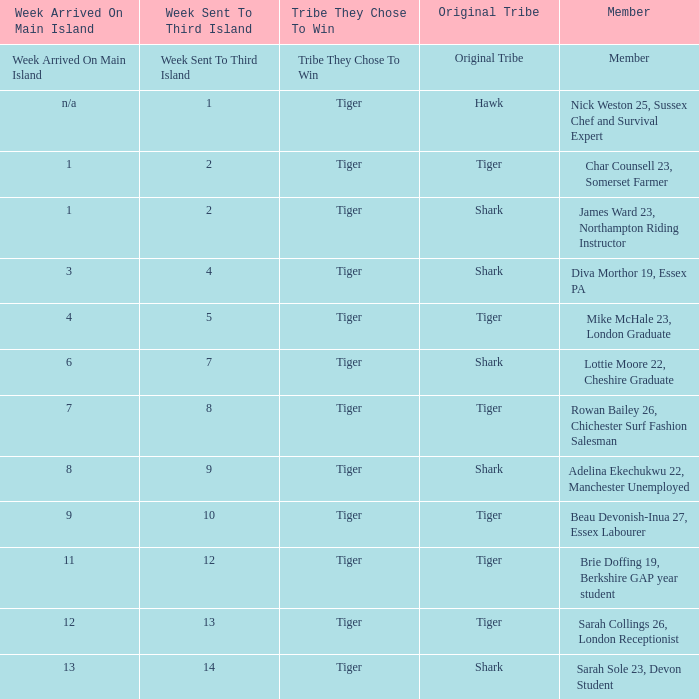Who was sent to the third island in week 1? Nick Weston 25, Sussex Chef and Survival Expert. Would you be able to parse every entry in this table? {'header': ['Week Arrived On Main Island', 'Week Sent To Third Island', 'Tribe They Chose To Win', 'Original Tribe', 'Member'], 'rows': [['Week Arrived On Main Island', 'Week Sent To Third Island', 'Tribe They Chose To Win', 'Original Tribe', 'Member'], ['n/a', '1', 'Tiger', 'Hawk', 'Nick Weston 25, Sussex Chef and Survival Expert'], ['1', '2', 'Tiger', 'Tiger', 'Char Counsell 23, Somerset Farmer'], ['1', '2', 'Tiger', 'Shark', 'James Ward 23, Northampton Riding Instructor'], ['3', '4', 'Tiger', 'Shark', 'Diva Morthor 19, Essex PA'], ['4', '5', 'Tiger', 'Tiger', 'Mike McHale 23, London Graduate'], ['6', '7', 'Tiger', 'Shark', 'Lottie Moore 22, Cheshire Graduate'], ['7', '8', 'Tiger', 'Tiger', 'Rowan Bailey 26, Chichester Surf Fashion Salesman'], ['8', '9', 'Tiger', 'Shark', 'Adelina Ekechukwu 22, Manchester Unemployed'], ['9', '10', 'Tiger', 'Tiger', 'Beau Devonish-Inua 27, Essex Labourer'], ['11', '12', 'Tiger', 'Tiger', 'Brie Doffing 19, Berkshire GAP year student'], ['12', '13', 'Tiger', 'Tiger', 'Sarah Collings 26, London Receptionist'], ['13', '14', 'Tiger', 'Shark', 'Sarah Sole 23, Devon Student']]} 